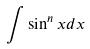Convert formula to latex. <formula><loc_0><loc_0><loc_500><loc_500>\int \sin ^ { n } x d x</formula> 